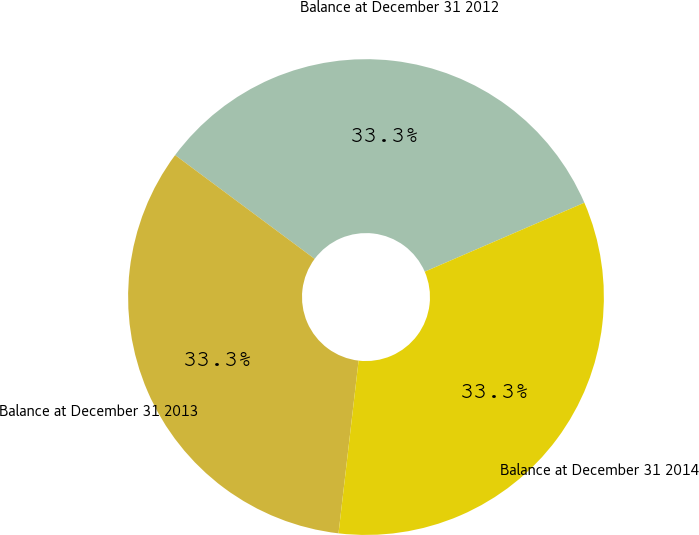<chart> <loc_0><loc_0><loc_500><loc_500><pie_chart><fcel>Balance at December 31 2012<fcel>Balance at December 31 2013<fcel>Balance at December 31 2014<nl><fcel>33.33%<fcel>33.33%<fcel>33.33%<nl></chart> 